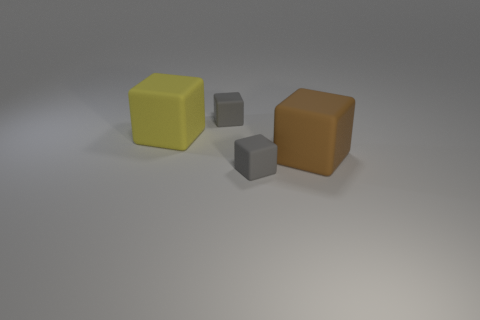What number of big yellow cubes are there?
Offer a terse response. 1. Do the tiny block that is behind the large brown matte block and the large matte block that is behind the big brown block have the same color?
Offer a very short reply. No. What number of other objects are the same size as the yellow object?
Provide a short and direct response. 1. There is a big rubber block behind the brown rubber block; what is its color?
Your response must be concise. Yellow. Is the gray block that is in front of the yellow matte cube made of the same material as the brown thing?
Make the answer very short. Yes. What number of big matte cubes are on the right side of the big yellow matte block and to the left of the brown rubber thing?
Offer a very short reply. 0. There is a big object that is right of the small matte block that is behind the large thing left of the brown block; what is its color?
Your answer should be compact. Brown. How many other things are there of the same shape as the yellow matte thing?
Provide a succinct answer. 3. Is there a large yellow rubber thing that is to the right of the rubber cube in front of the big brown object?
Offer a terse response. No. How many rubber things are big brown cubes or yellow things?
Provide a short and direct response. 2. 